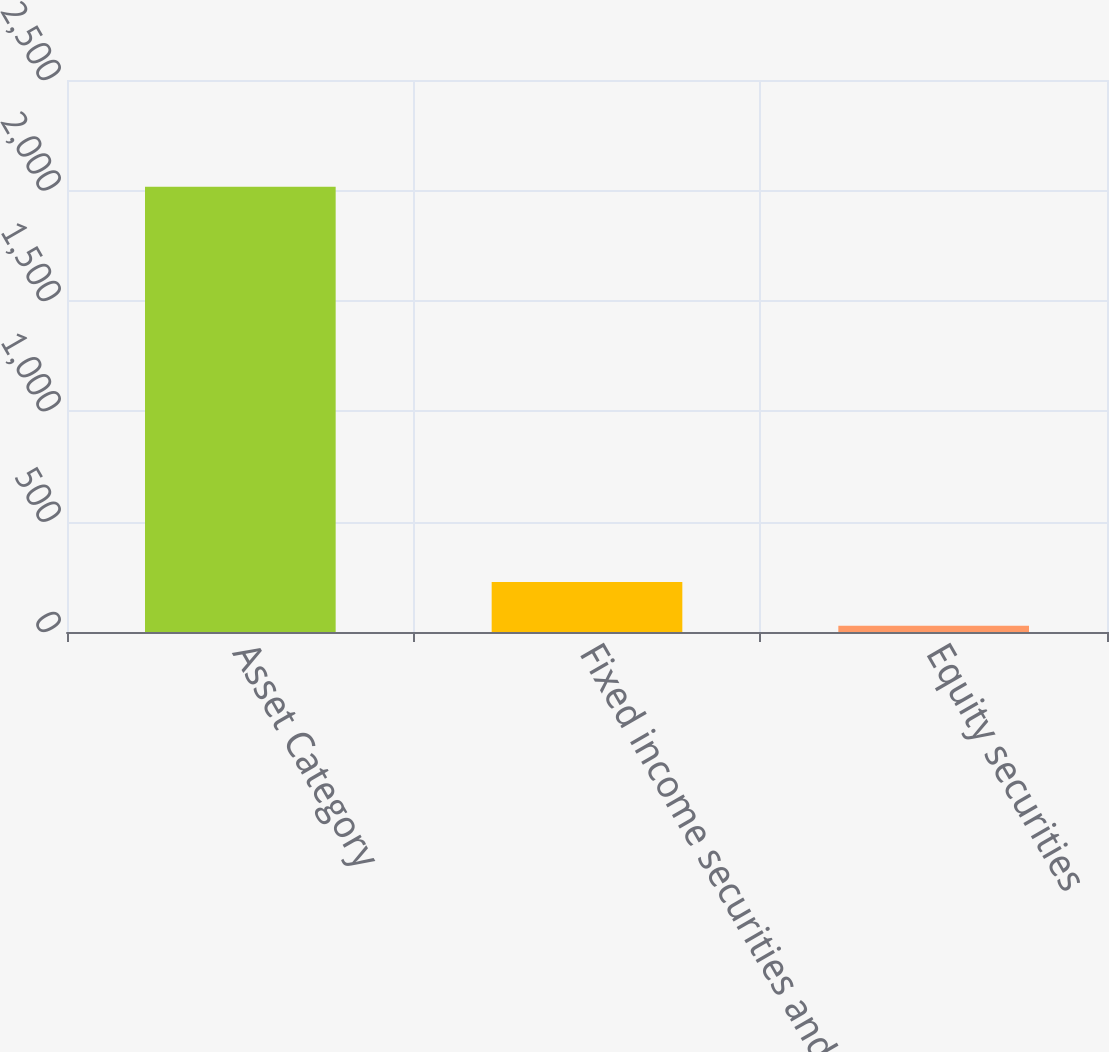Convert chart to OTSL. <chart><loc_0><loc_0><loc_500><loc_500><bar_chart><fcel>Asset Category<fcel>Fixed income securities and<fcel>Equity securities<nl><fcel>2016<fcel>226.8<fcel>28<nl></chart> 